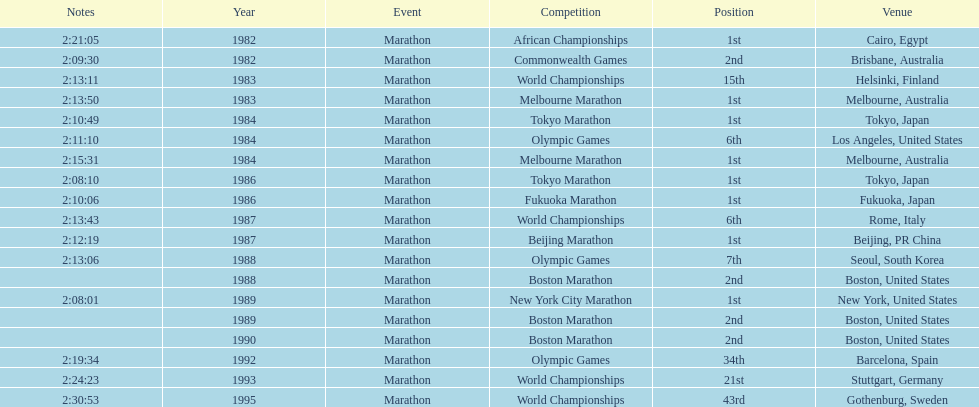In what year did the runner participate in the most marathons? 1984. 